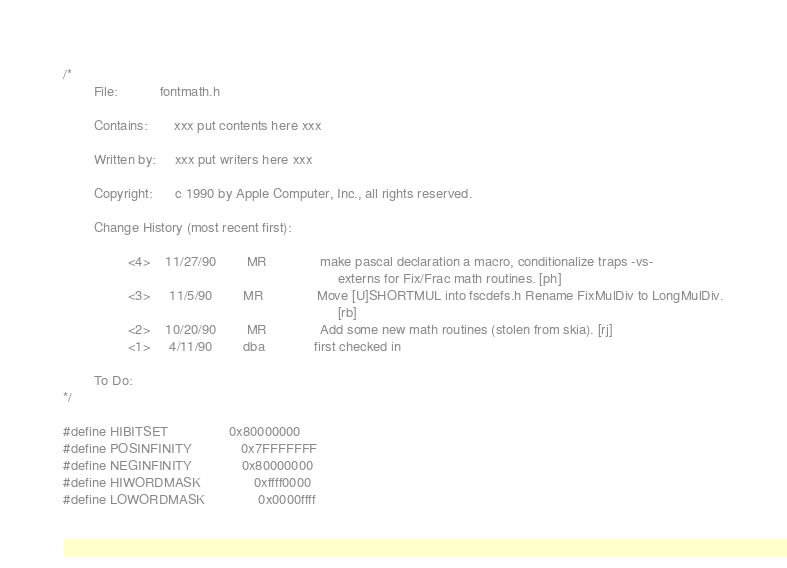Convert code to text. <code><loc_0><loc_0><loc_500><loc_500><_C_>/*
        File:           fontmath.h

        Contains:       xxx put contents here xxx

        Written by:     xxx put writers here xxx

        Copyright:      c 1990 by Apple Computer, Inc., all rights reserved.

        Change History (most recent first):

                 <4>    11/27/90        MR              make pascal declaration a macro, conditionalize traps -vs-
                                                                        externs for Fix/Frac math routines. [ph]
                 <3>     11/5/90        MR              Move [U]SHORTMUL into fscdefs.h Rename FixMulDiv to LongMulDiv.
                                                                        [rb]
                 <2>    10/20/90        MR              Add some new math routines (stolen from skia). [rj]
                 <1>     4/11/90        dba             first checked in

        To Do:
*/

#define HIBITSET                0x80000000
#define POSINFINITY             0x7FFFFFFF
#define NEGINFINITY             0x80000000
#define HIWORDMASK              0xffff0000
#define LOWORDMASK              0x0000ffff</code> 